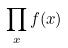<formula> <loc_0><loc_0><loc_500><loc_500>\prod _ { x } f ( x )</formula> 